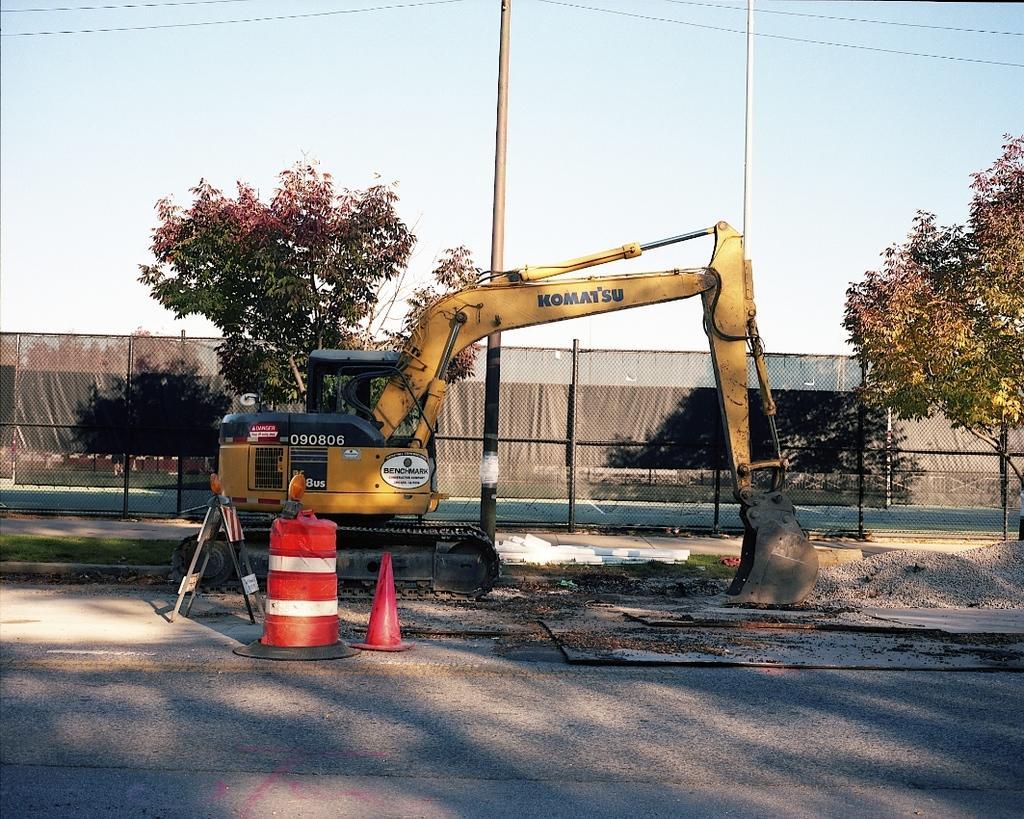Please provide a concise description of this image. In this image there is a crane. There is a traffic cone cup, plastic container on the road. There are piles of stones. In the background of the image there is a metal fence. There are trees, poles and sky. 